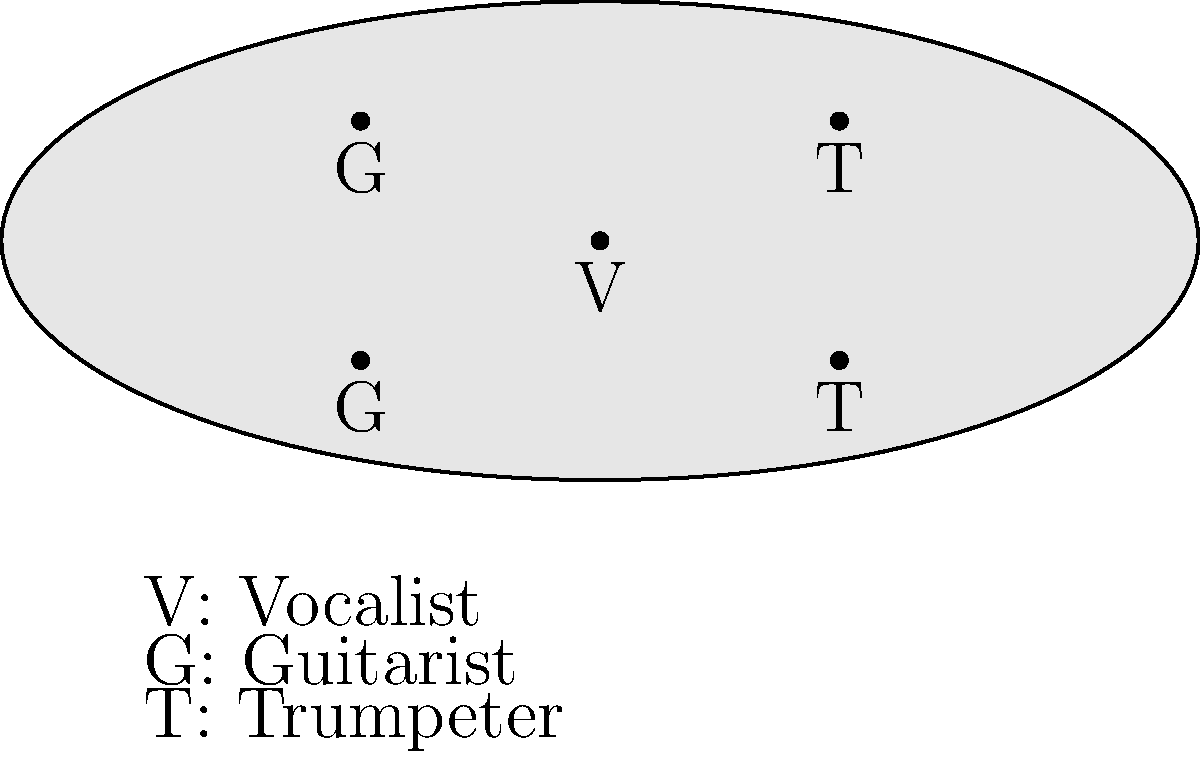A mariachi band is performing on a circular stage. The vocalist (V) is at the center, surrounded by two guitarists (G) and two trumpeters (T). If the band needs to rearrange so that no two musicians playing the same instrument are adjacent, and the vocalist remains in the center, how many valid arrangements are possible? Let's approach this step-by-step:

1) The vocalist (V) must remain in the center, so we only need to arrange the other four musicians.

2) We have two guitarists (G) and two trumpeters (T). They need to be arranged alternately around the vocalist.

3) There are two possible patterns:
   - G T G T
   - T G T G

4) For each pattern, we have two choices:
   a) Keep it as is
   b) Rotate it (which gives a different arrangement)

5) So, for the G T G T pattern:
   - G T G T
   - T G T G (rotated)

6) And for the T G T G pattern:
   - T G T G
   - G T G T (rotated)

7) However, we can see that the rotated versions of each pattern are actually the same as the original version of the other pattern.

8) Therefore, there are only two unique arrangements:
   - G T G T
   - T G T G

Thus, there are $2$ valid arrangements.
Answer: 2 